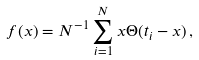<formula> <loc_0><loc_0><loc_500><loc_500>f ( x ) = N ^ { - 1 } \sum _ { i = 1 } ^ { N } x \Theta ( t _ { i } - x ) \, ,</formula> 